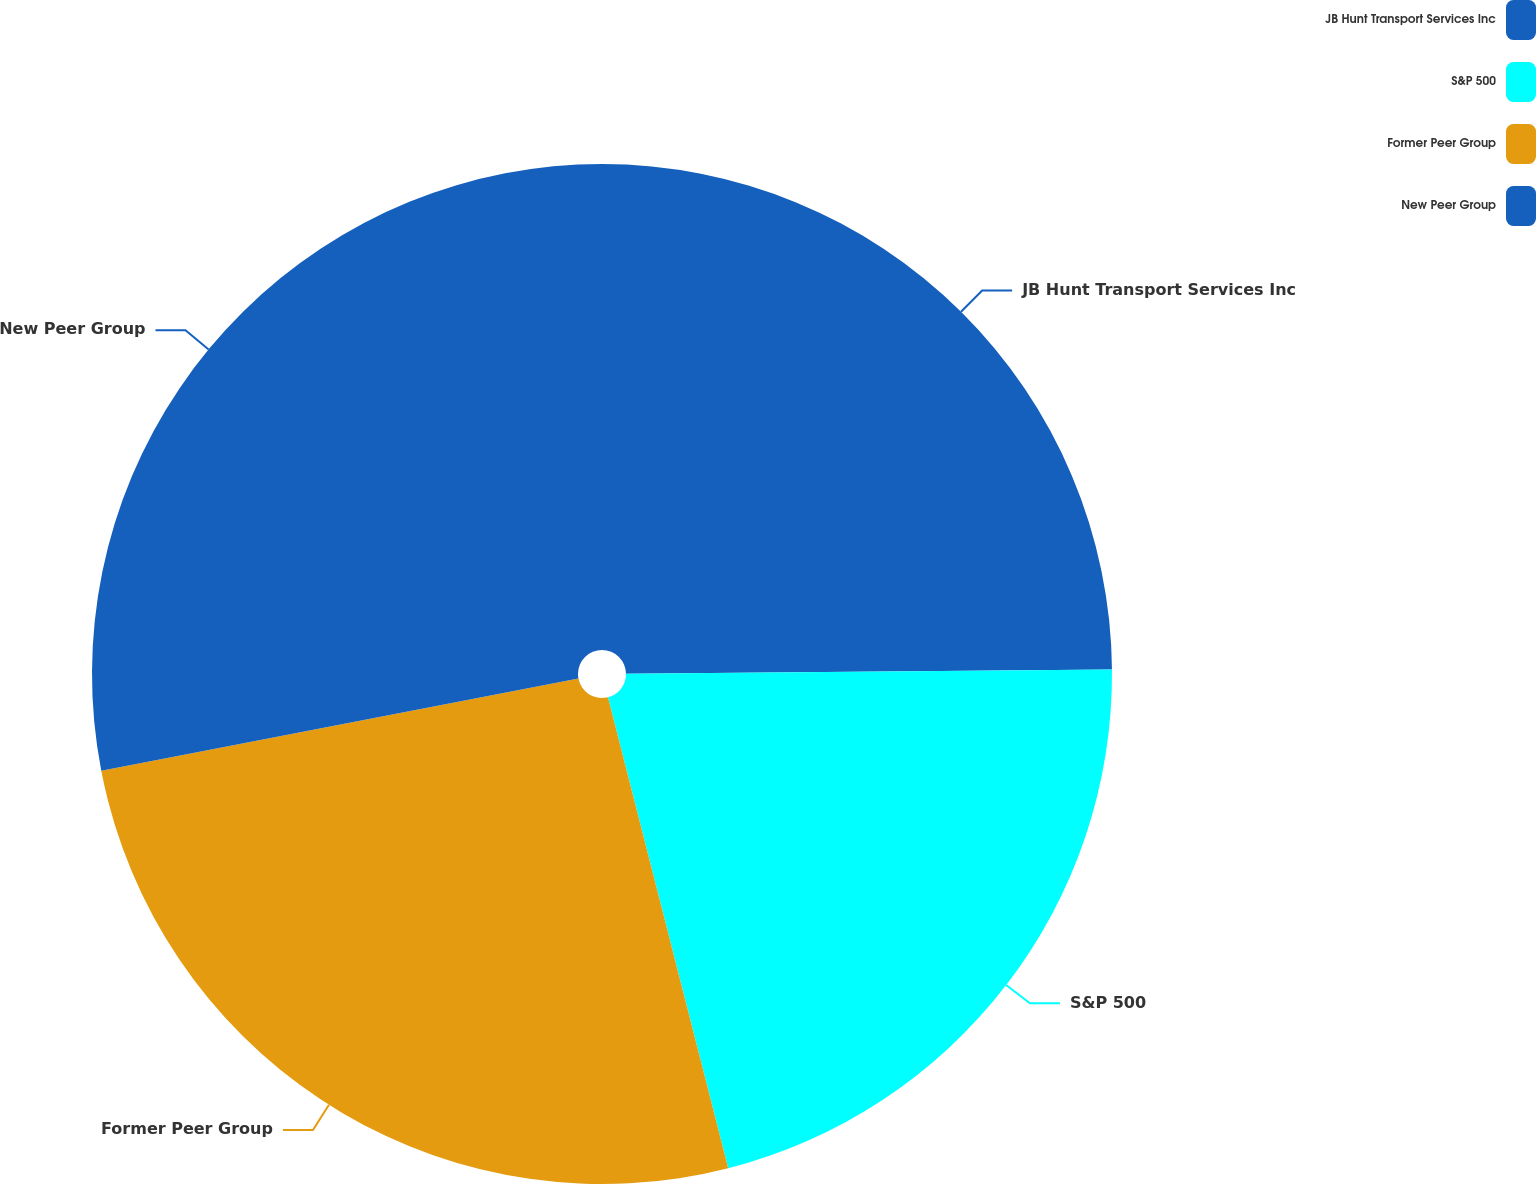<chart> <loc_0><loc_0><loc_500><loc_500><pie_chart><fcel>JB Hunt Transport Services Inc<fcel>S&P 500<fcel>Former Peer Group<fcel>New Peer Group<nl><fcel>24.86%<fcel>21.16%<fcel>25.94%<fcel>28.04%<nl></chart> 